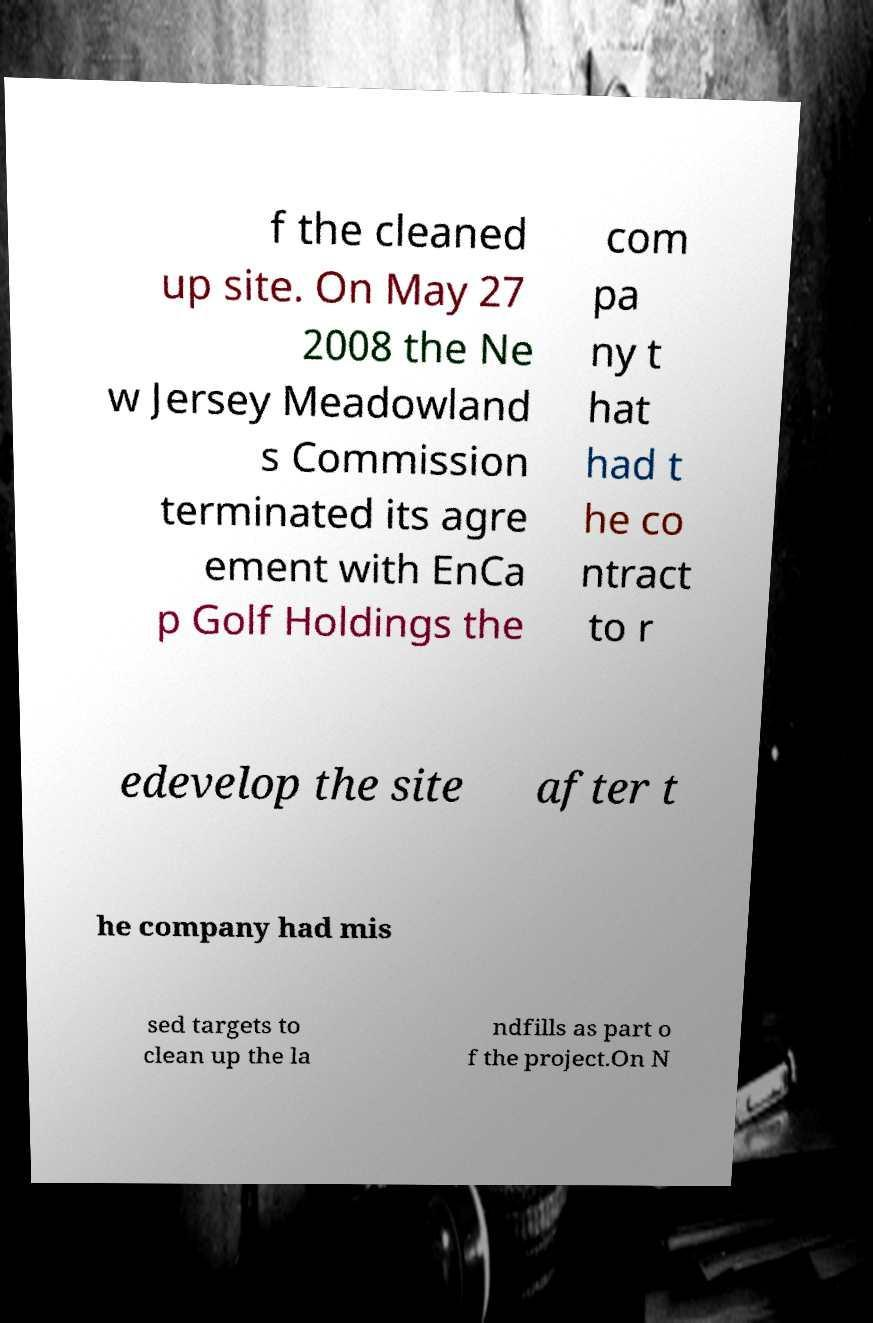Please read and relay the text visible in this image. What does it say? f the cleaned up site. On May 27 2008 the Ne w Jersey Meadowland s Commission terminated its agre ement with EnCa p Golf Holdings the com pa ny t hat had t he co ntract to r edevelop the site after t he company had mis sed targets to clean up the la ndfills as part o f the project.On N 